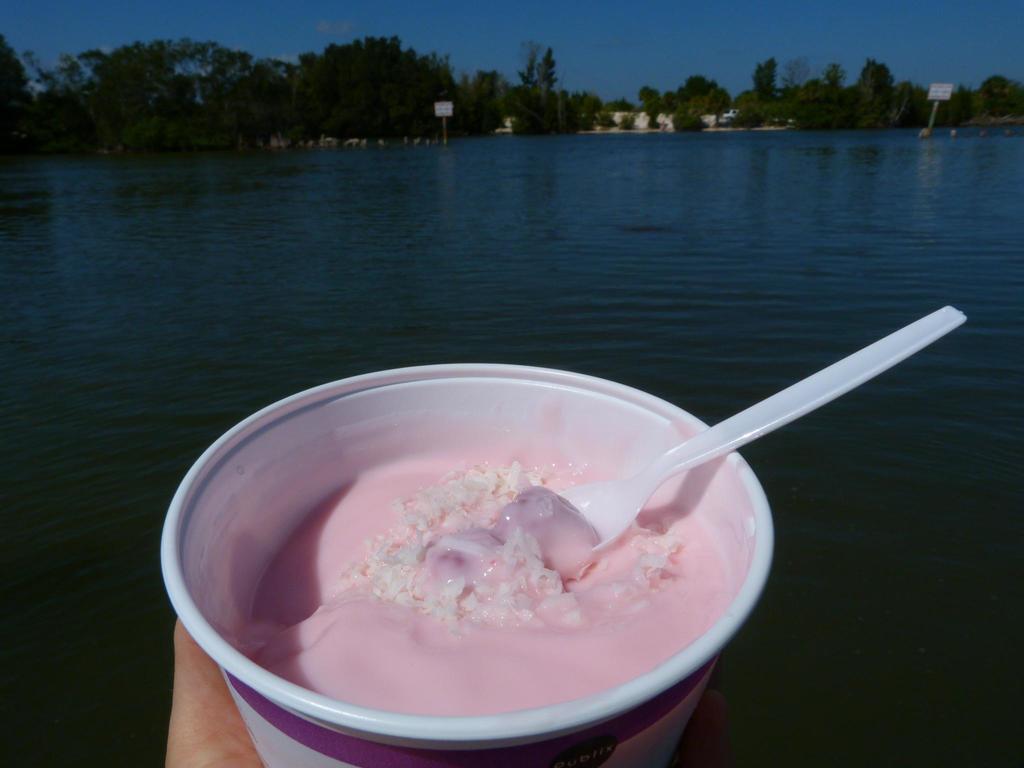Describe this image in one or two sentences. A sea where there are some trees and which has some food content in the cup along with the spoon. 